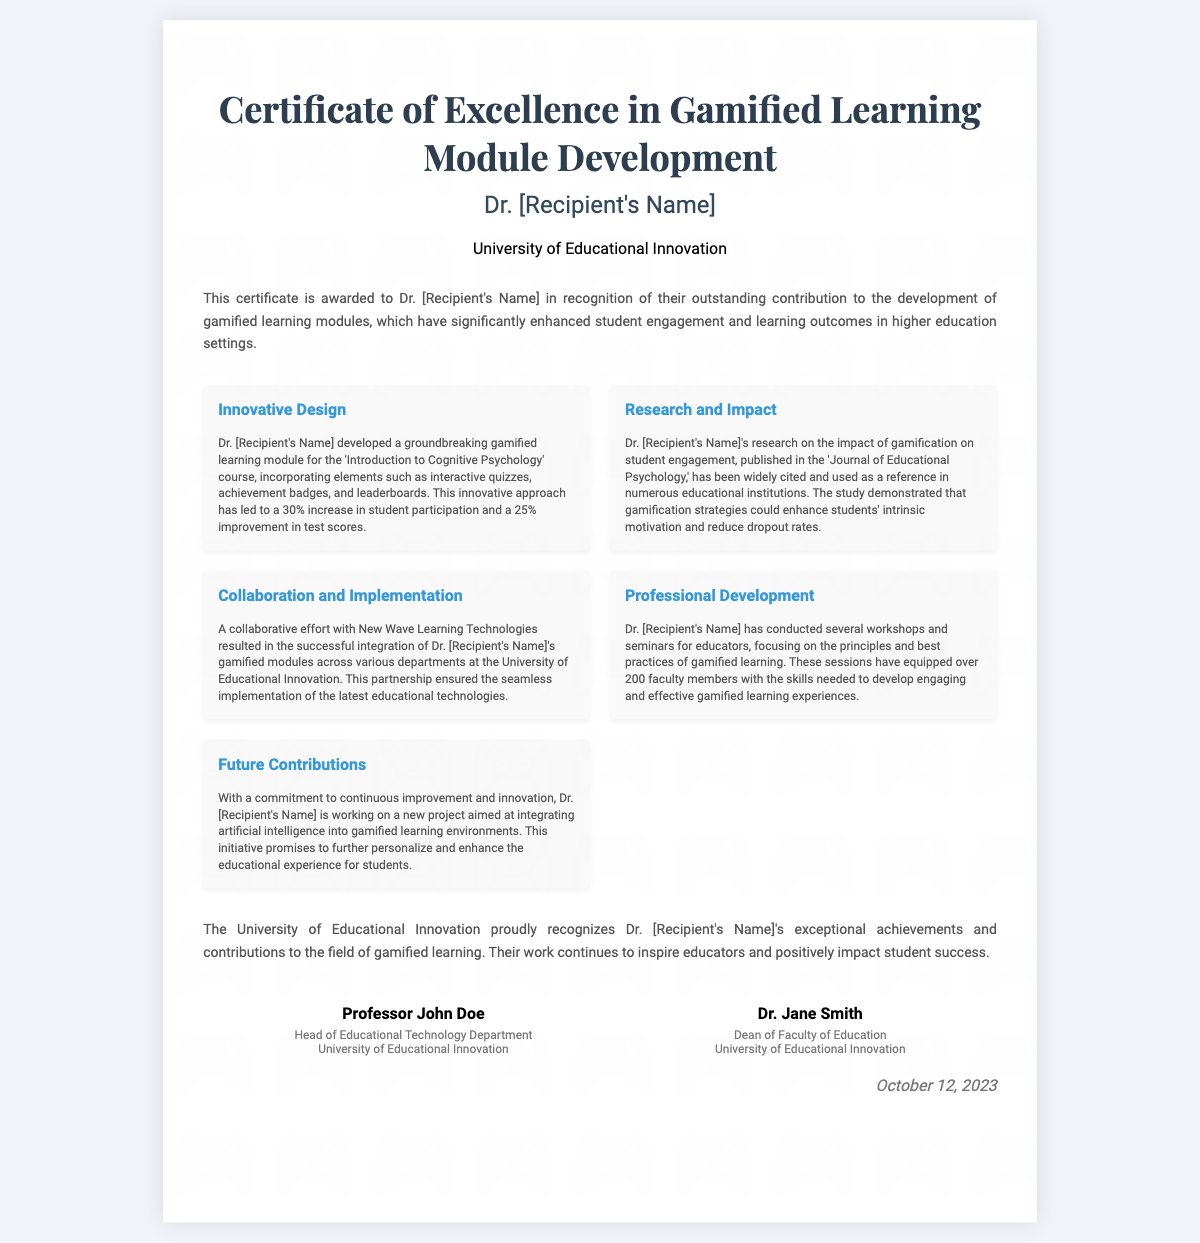What is the recipient's name? The recipient's name is indicated in the certificate but is noted as [Recipient's Name].
Answer: [Recipient's Name] What organization issued the certificate? The organization name is mentioned in the header as the issuer of the certificate.
Answer: University of Educational Innovation What is the increase in student participation due to the gamified module? The document states that the gamified learning module led to a 30% increase in student participation.
Answer: 30% What is the publication in which Dr. [Recipient's Name]'s research was published? The publication is referenced concerning the impact of gamification on student engagement.
Answer: Journal of Educational Psychology What technology was integrated with the gamified modules? The collaboration name indicates the technology integrated with the gamified learning modules.
Answer: New Wave Learning Technologies Who is the Dean of Faculty of Education? The certificate includes names and titles, identifying the Dean.
Answer: Dr. Jane Smith What is the date of the certificate? The date is explicitly stated at the bottom of the document.
Answer: October 12, 2023 How many faculty members were equipped with gamified learning skills? The number of faculty members who attended the workshops is mentioned.
Answer: 200 What future project is Dr. [Recipient's Name] working on? The document outlines Dr. [Recipient's Name]'s upcoming focus area.
Answer: integrating artificial intelligence into gamified learning environments What is one outcome of Dr. [Recipient's Name]'s research? The document specifies a notable impact of gamification research on students.
Answer: reduced dropout rates 